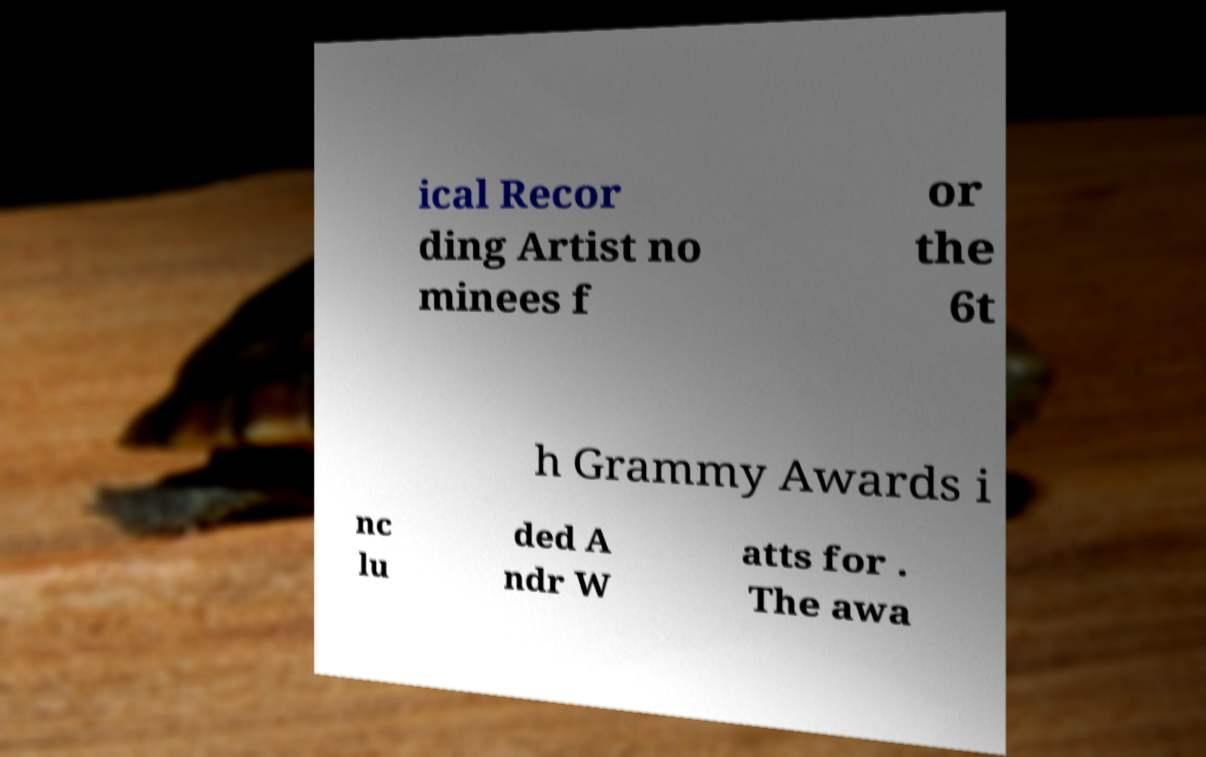Could you extract and type out the text from this image? ical Recor ding Artist no minees f or the 6t h Grammy Awards i nc lu ded A ndr W atts for . The awa 